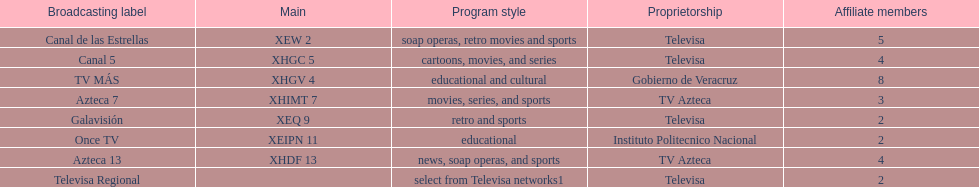Tell me the number of stations tv azteca owns. 2. 